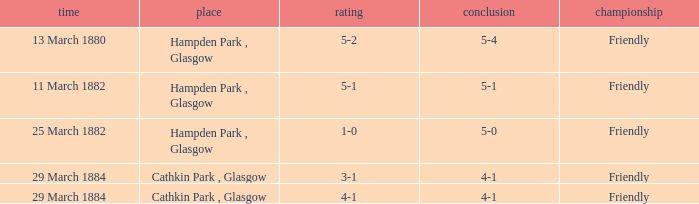Which competition had a 4-1 result, and a score of 4-1? Friendly. 